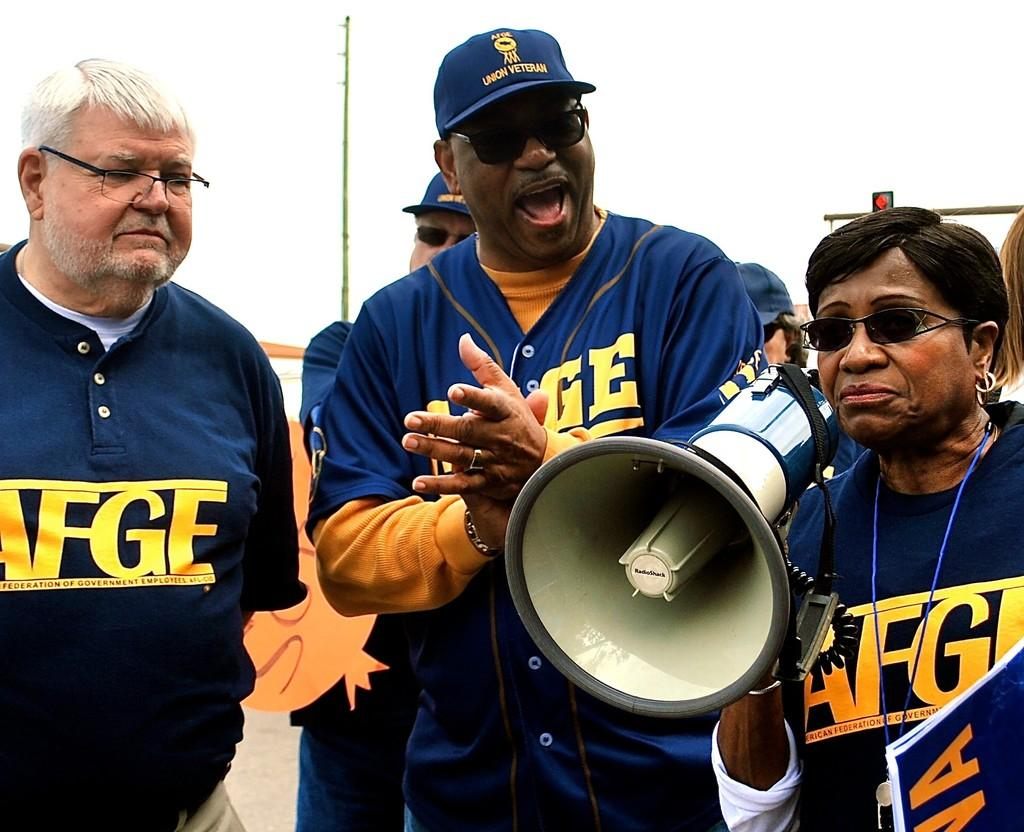<image>
Describe the image concisely. Three people stand together wearing AFGE shirts, one of which has a bull horn. 